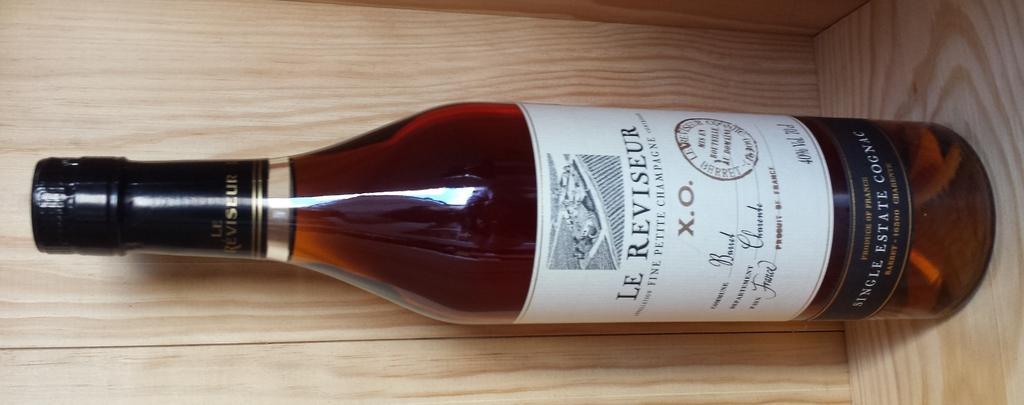What is the name of the winery?
Provide a succinct answer. Le reviseur. What is the name of the wine?
Provide a succinct answer. Le reviseur. 